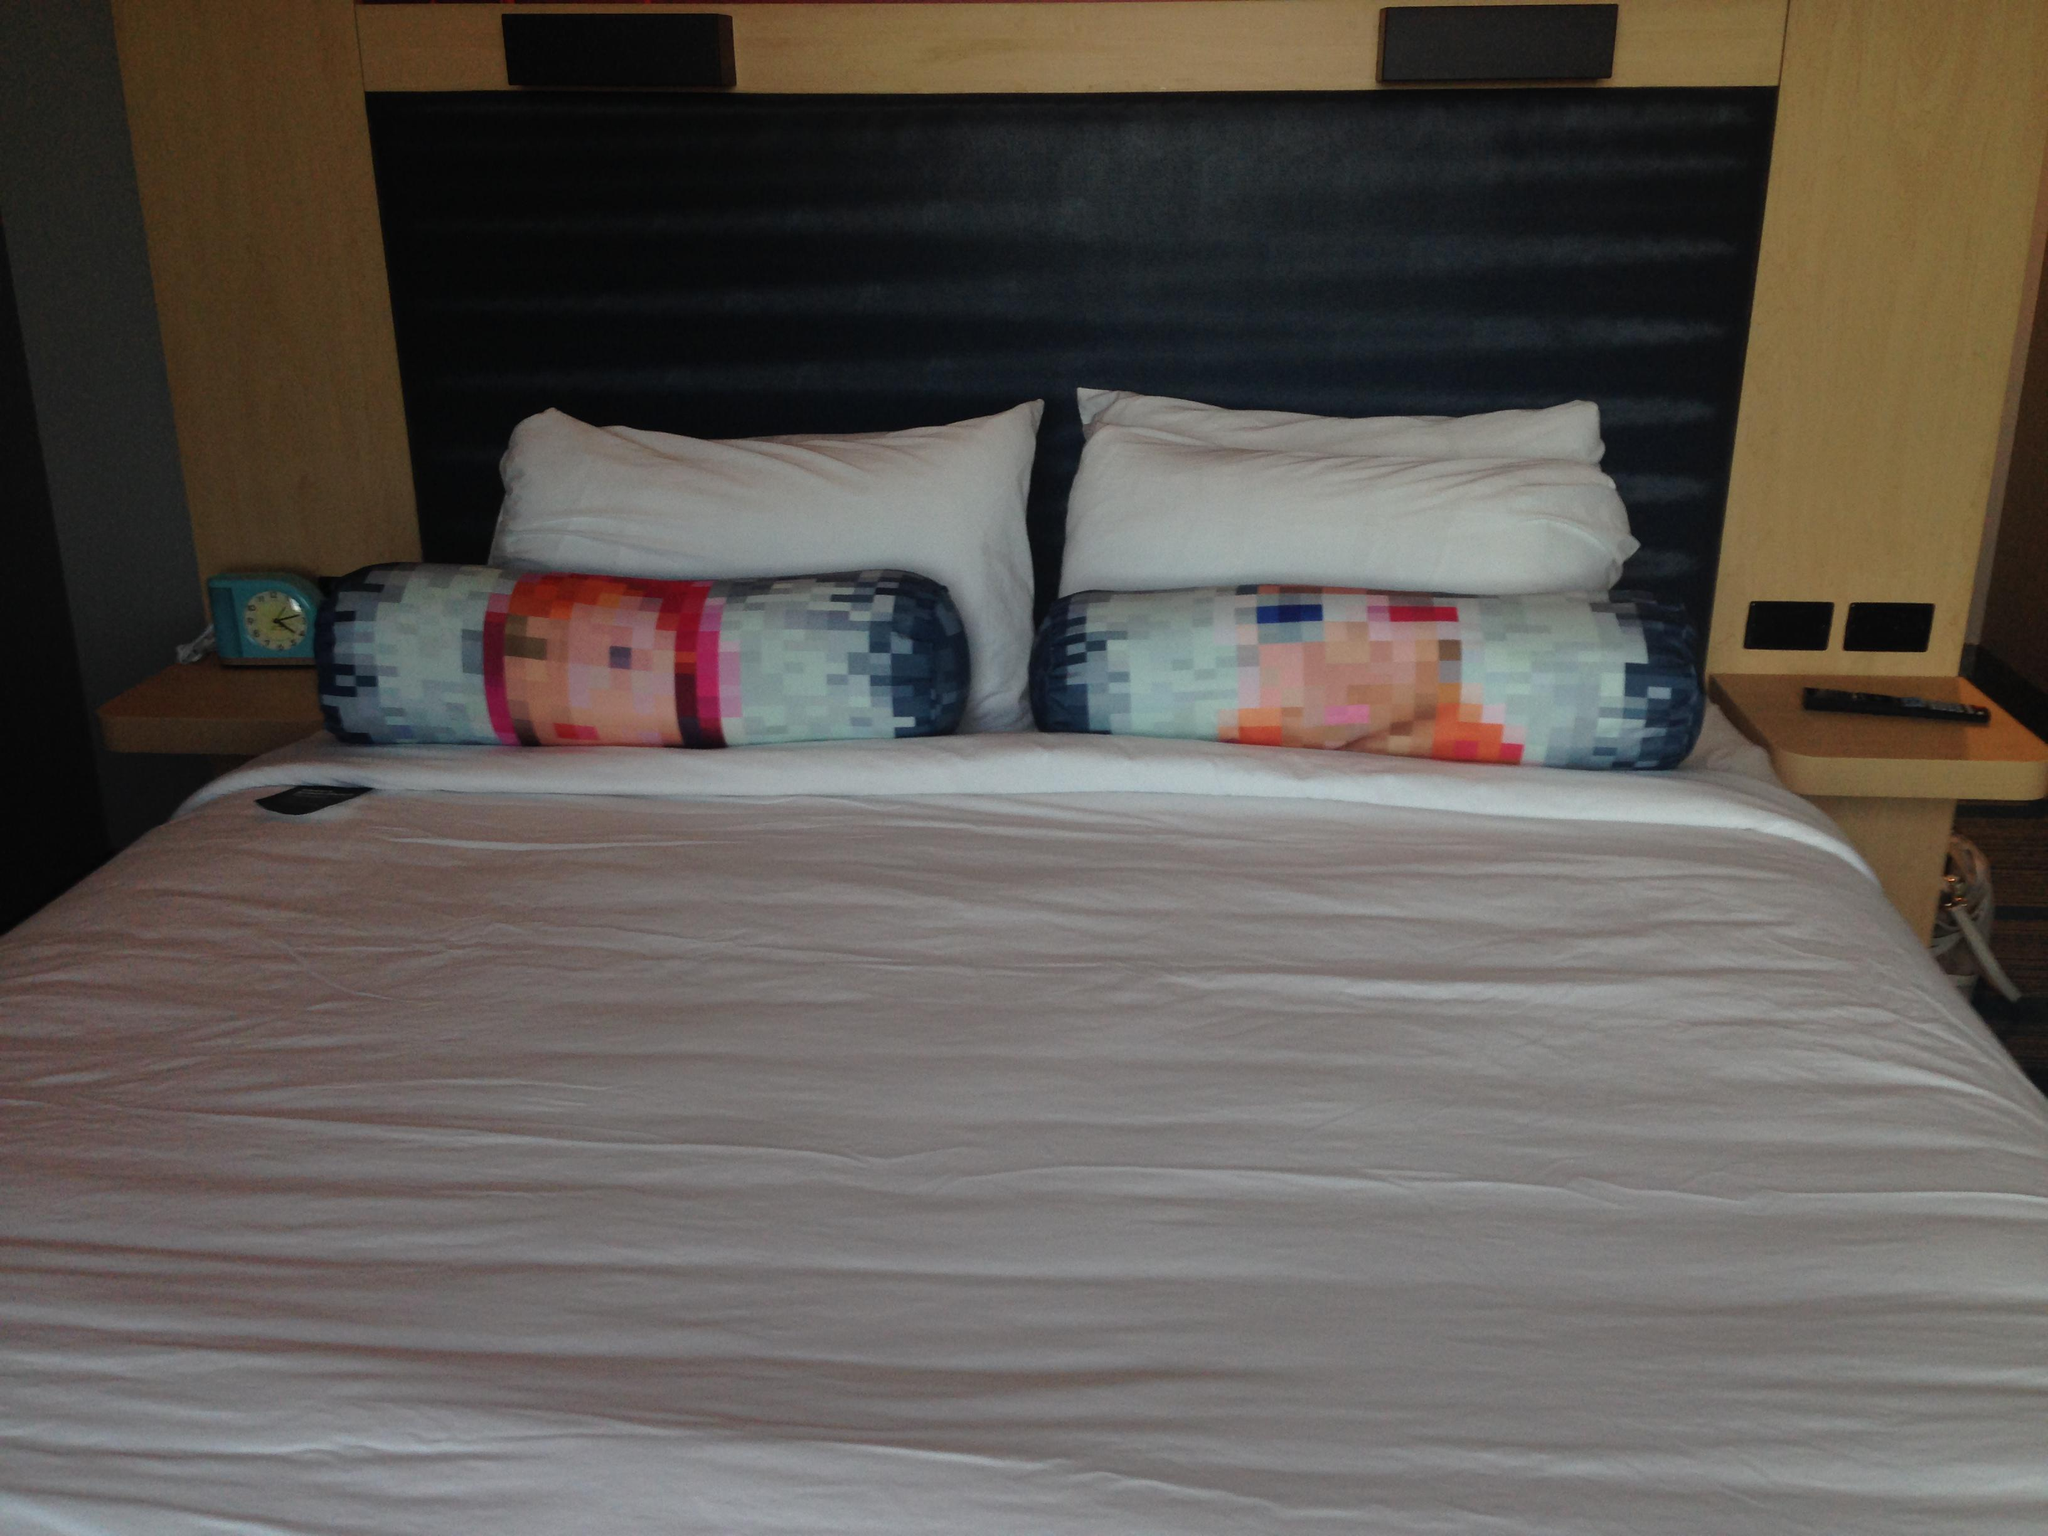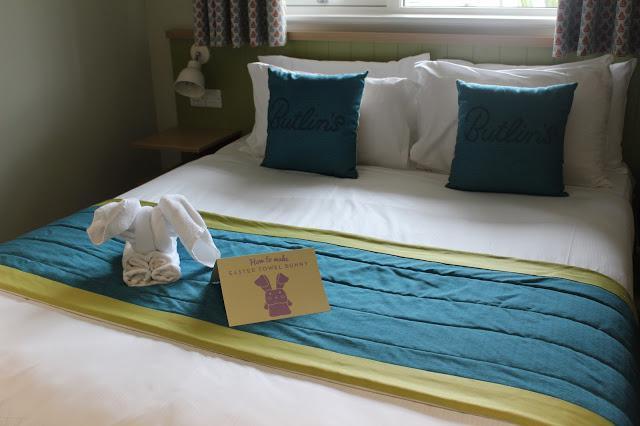The first image is the image on the left, the second image is the image on the right. For the images displayed, is the sentence "The image to the left is clearly a bed." factually correct? Answer yes or no. Yes. The first image is the image on the left, the second image is the image on the right. Evaluate the accuracy of this statement regarding the images: "An image shows a bed with a blue bedding component and two square non-white pillows facing forward.". Is it true? Answer yes or no. Yes. 